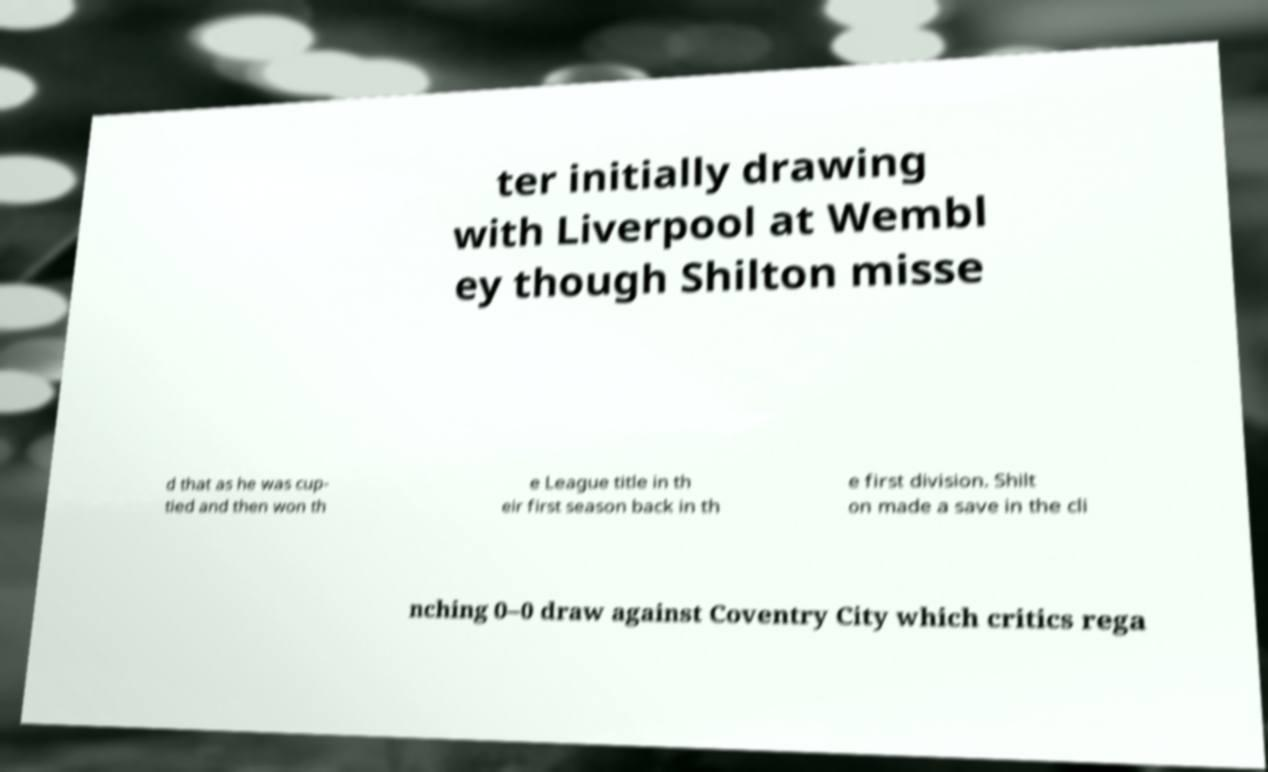For documentation purposes, I need the text within this image transcribed. Could you provide that? ter initially drawing with Liverpool at Wembl ey though Shilton misse d that as he was cup- tied and then won th e League title in th eir first season back in th e first division. Shilt on made a save in the cli nching 0–0 draw against Coventry City which critics rega 